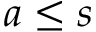Convert formula to latex. <formula><loc_0><loc_0><loc_500><loc_500>a \leq s</formula> 